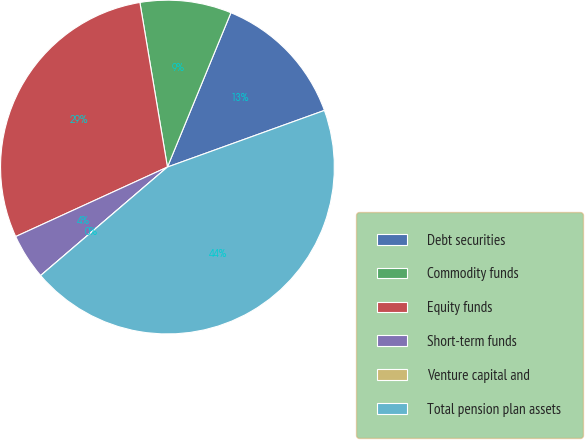Convert chart to OTSL. <chart><loc_0><loc_0><loc_500><loc_500><pie_chart><fcel>Debt securities<fcel>Commodity funds<fcel>Equity funds<fcel>Short-term funds<fcel>Venture capital and<fcel>Total pension plan assets<nl><fcel>13.28%<fcel>8.85%<fcel>29.2%<fcel>4.43%<fcel>0.0%<fcel>44.25%<nl></chart> 